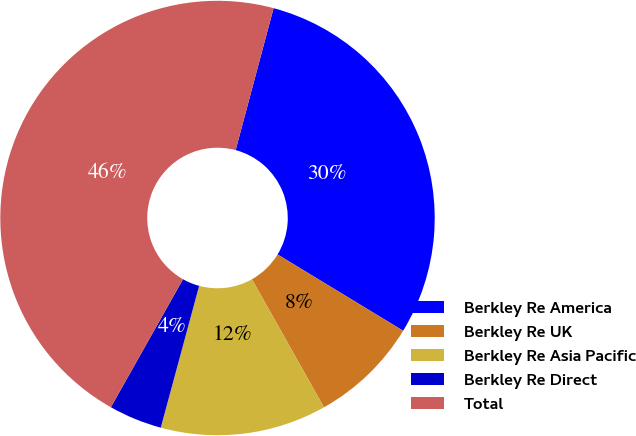Convert chart to OTSL. <chart><loc_0><loc_0><loc_500><loc_500><pie_chart><fcel>Berkley Re America<fcel>Berkley Re UK<fcel>Berkley Re Asia Pacific<fcel>Berkley Re Direct<fcel>Total<nl><fcel>29.53%<fcel>8.16%<fcel>12.36%<fcel>3.96%<fcel>45.99%<nl></chart> 